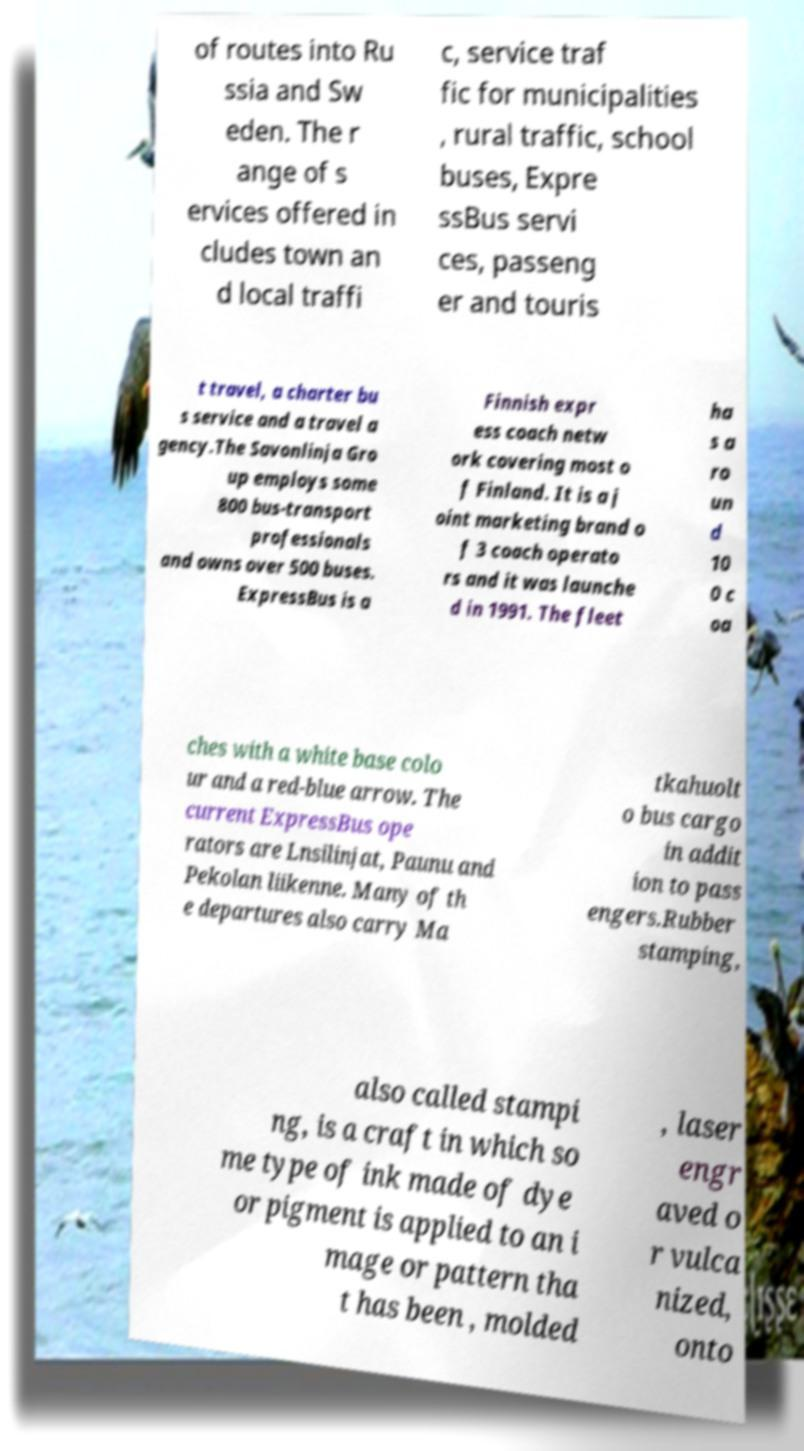What messages or text are displayed in this image? I need them in a readable, typed format. of routes into Ru ssia and Sw eden. The r ange of s ervices offered in cludes town an d local traffi c, service traf fic for municipalities , rural traffic, school buses, Expre ssBus servi ces, passeng er and touris t travel, a charter bu s service and a travel a gency.The Savonlinja Gro up employs some 800 bus-transport professionals and owns over 500 buses. ExpressBus is a Finnish expr ess coach netw ork covering most o f Finland. It is a j oint marketing brand o f 3 coach operato rs and it was launche d in 1991. The fleet ha s a ro un d 10 0 c oa ches with a white base colo ur and a red-blue arrow. The current ExpressBus ope rators are Lnsilinjat, Paunu and Pekolan liikenne. Many of th e departures also carry Ma tkahuolt o bus cargo in addit ion to pass engers.Rubber stamping, also called stampi ng, is a craft in which so me type of ink made of dye or pigment is applied to an i mage or pattern tha t has been , molded , laser engr aved o r vulca nized, onto 